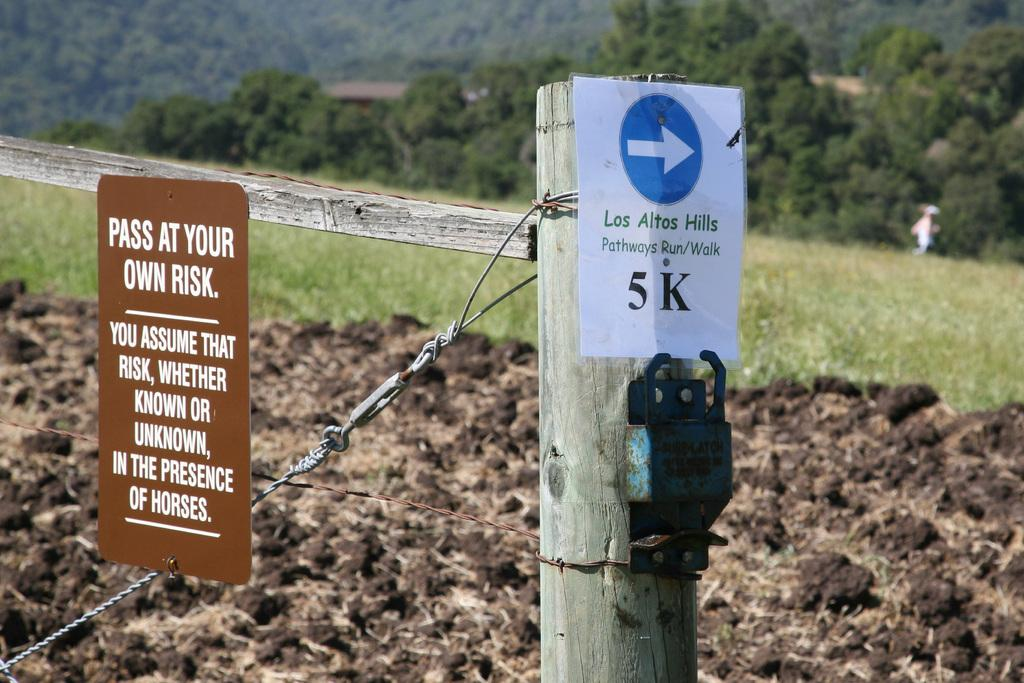What is the main object in the image? There is a wooden pole in the image. What is attached to the wooden pole? A paper is attached to the wooden pole. What type of terrain is visible in the image? There is sand and grass visible in the image. What type of vegetation can be seen in the image? There are green trees in the image. What type of body of water can be seen in the image? There is no body of water, such as an ocean, present in the image. What substance is being used to create the paper attached to the wooden pole? The facts provided do not mention the substance used to create the paper, so it cannot be determined from the image. 